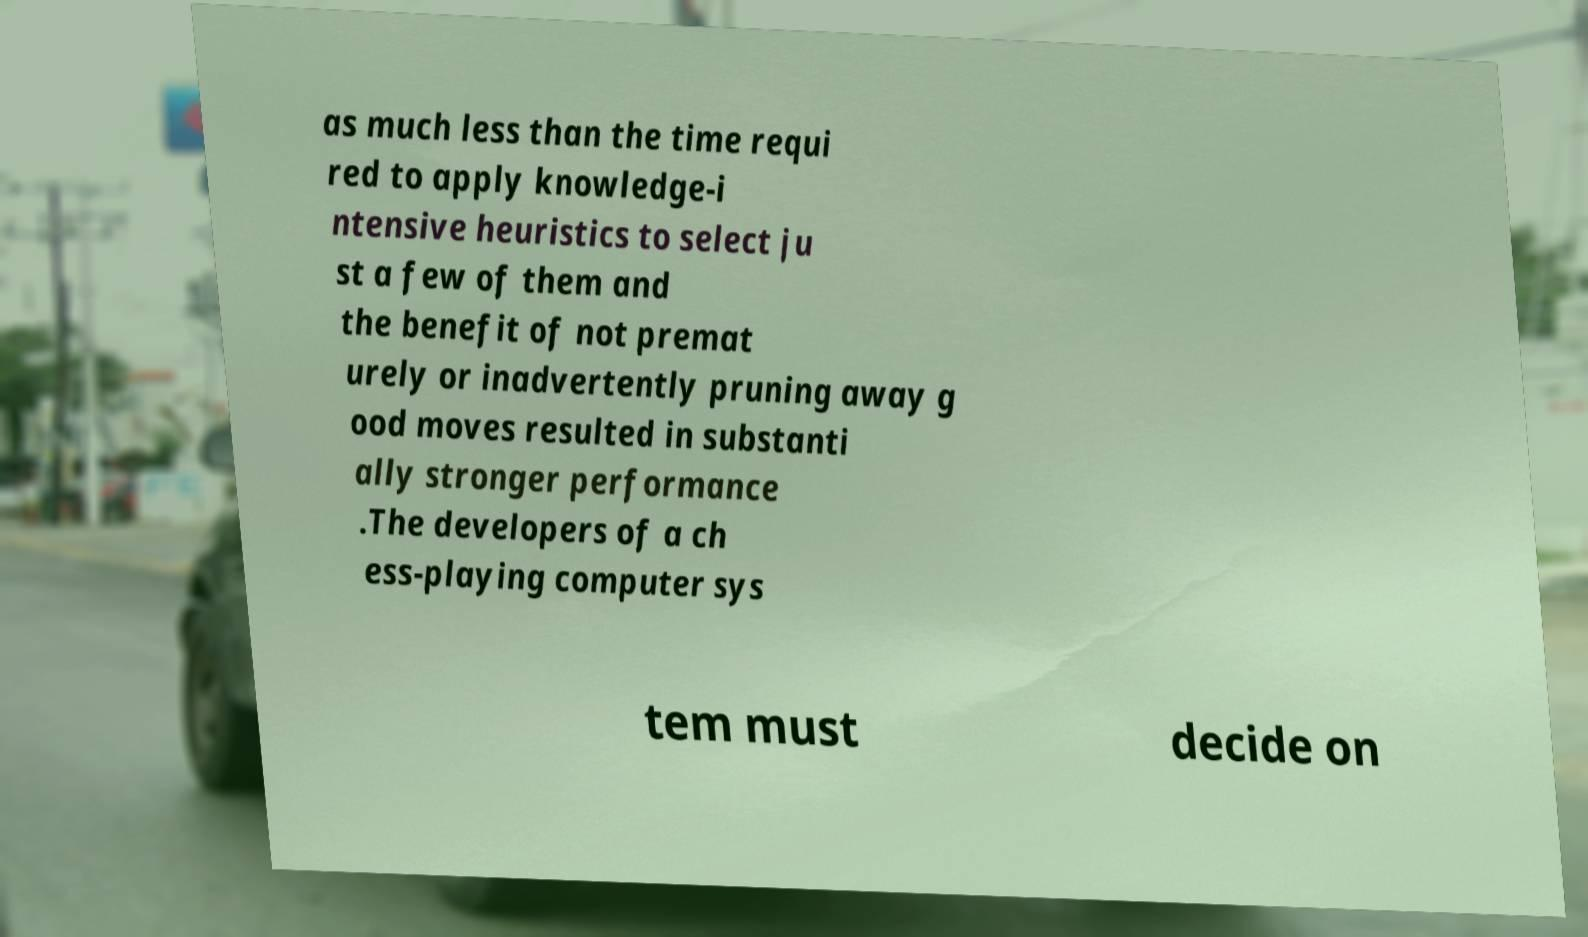What messages or text are displayed in this image? I need them in a readable, typed format. as much less than the time requi red to apply knowledge-i ntensive heuristics to select ju st a few of them and the benefit of not premat urely or inadvertently pruning away g ood moves resulted in substanti ally stronger performance .The developers of a ch ess-playing computer sys tem must decide on 